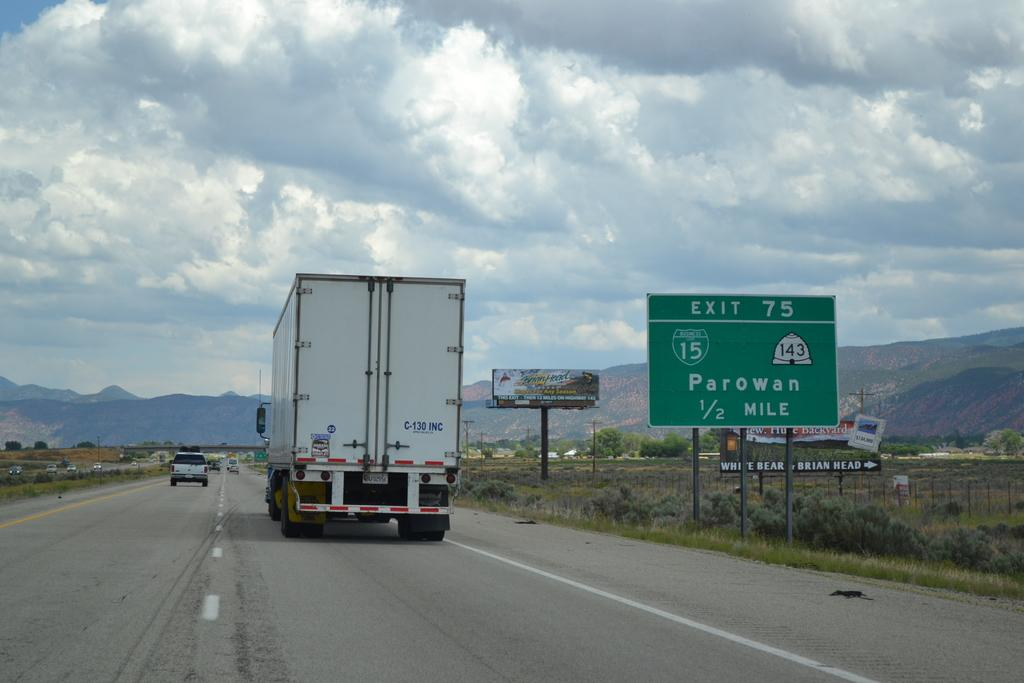What can be seen on the road in the image? There are motor vehicles on the road in the image. What type of signs are present in the image? There are sign boards and advertisement boards in the image. What type of vegetation is visible in the image? There is grass, bushes, and hills visible in the image. What structures can be seen in the image? There are poles in the image. What is visible in the sky in the image? The sky is visible in the image, and there are clouds present. What type of trousers is the lawyer wearing in the image? There is no lawyer or trousers present in the image. What type of toy can be seen playing with the clouds in the image? There is no toy present in the image, and the clouds are not being played with. 